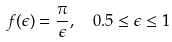Convert formula to latex. <formula><loc_0><loc_0><loc_500><loc_500>f ( \epsilon ) = \frac { \pi } { \epsilon } , \ \ 0 . 5 \leq \epsilon \leq 1</formula> 